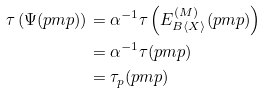Convert formula to latex. <formula><loc_0><loc_0><loc_500><loc_500>\tau \left ( \Psi ( p m p ) \right ) & = \alpha ^ { - 1 } \tau \left ( E ^ { ( M ) } _ { B \langle X \rangle } ( p m p ) \right ) \\ & = \alpha ^ { - 1 } \tau ( p m p ) \\ & = \tau _ { p } ( p m p )</formula> 